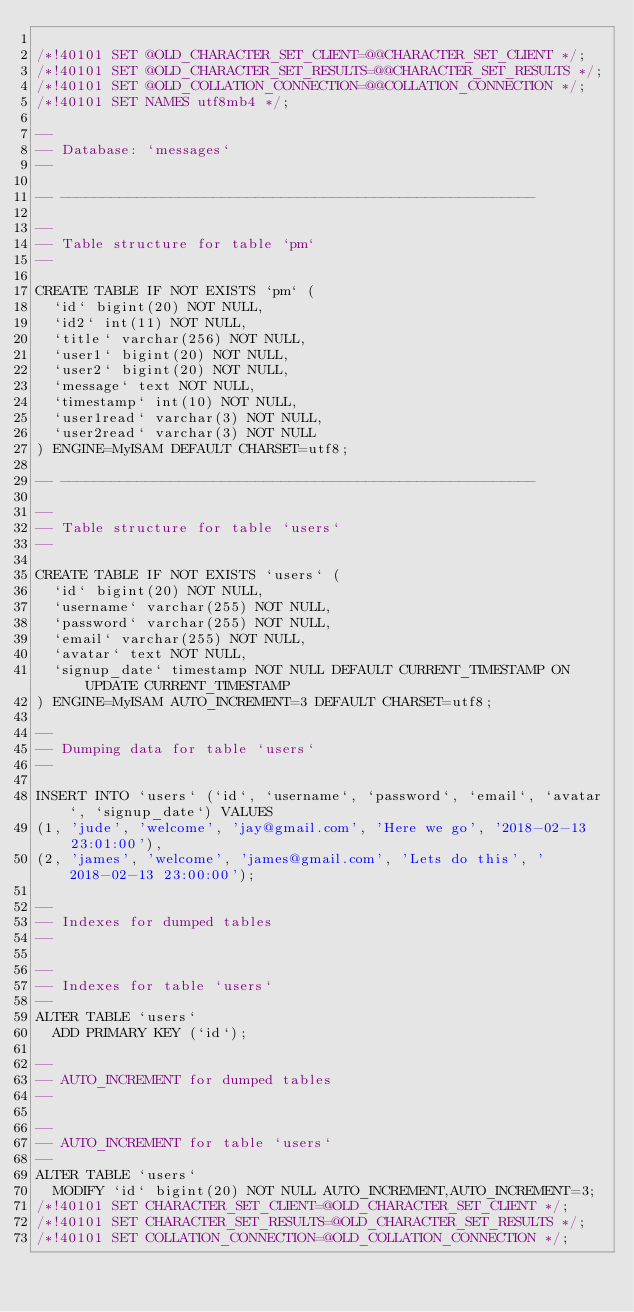Convert code to text. <code><loc_0><loc_0><loc_500><loc_500><_SQL_>
/*!40101 SET @OLD_CHARACTER_SET_CLIENT=@@CHARACTER_SET_CLIENT */;
/*!40101 SET @OLD_CHARACTER_SET_RESULTS=@@CHARACTER_SET_RESULTS */;
/*!40101 SET @OLD_COLLATION_CONNECTION=@@COLLATION_CONNECTION */;
/*!40101 SET NAMES utf8mb4 */;

--
-- Database: `messages`
--

-- --------------------------------------------------------

--
-- Table structure for table `pm`
--

CREATE TABLE IF NOT EXISTS `pm` (
  `id` bigint(20) NOT NULL,
  `id2` int(11) NOT NULL,
  `title` varchar(256) NOT NULL,
  `user1` bigint(20) NOT NULL,
  `user2` bigint(20) NOT NULL,
  `message` text NOT NULL,
  `timestamp` int(10) NOT NULL,
  `user1read` varchar(3) NOT NULL,
  `user2read` varchar(3) NOT NULL
) ENGINE=MyISAM DEFAULT CHARSET=utf8;

-- --------------------------------------------------------

--
-- Table structure for table `users`
--

CREATE TABLE IF NOT EXISTS `users` (
  `id` bigint(20) NOT NULL,
  `username` varchar(255) NOT NULL,
  `password` varchar(255) NOT NULL,
  `email` varchar(255) NOT NULL,
  `avatar` text NOT NULL,
  `signup_date` timestamp NOT NULL DEFAULT CURRENT_TIMESTAMP ON UPDATE CURRENT_TIMESTAMP
) ENGINE=MyISAM AUTO_INCREMENT=3 DEFAULT CHARSET=utf8;

--
-- Dumping data for table `users`
--

INSERT INTO `users` (`id`, `username`, `password`, `email`, `avatar`, `signup_date`) VALUES
(1, 'jude', 'welcome', 'jay@gmail.com', 'Here we go', '2018-02-13 23:01:00'),
(2, 'james', 'welcome', 'james@gmail.com', 'Lets do this', '2018-02-13 23:00:00');

--
-- Indexes for dumped tables
--

--
-- Indexes for table `users`
--
ALTER TABLE `users`
  ADD PRIMARY KEY (`id`);

--
-- AUTO_INCREMENT for dumped tables
--

--
-- AUTO_INCREMENT for table `users`
--
ALTER TABLE `users`
  MODIFY `id` bigint(20) NOT NULL AUTO_INCREMENT,AUTO_INCREMENT=3;
/*!40101 SET CHARACTER_SET_CLIENT=@OLD_CHARACTER_SET_CLIENT */;
/*!40101 SET CHARACTER_SET_RESULTS=@OLD_CHARACTER_SET_RESULTS */;
/*!40101 SET COLLATION_CONNECTION=@OLD_COLLATION_CONNECTION */;
</code> 